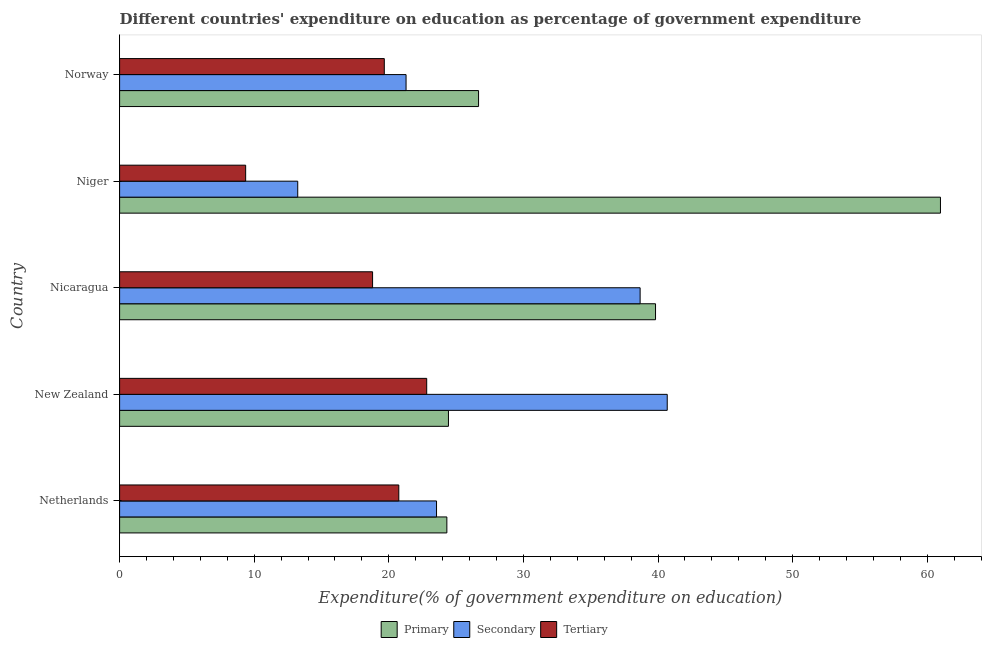How many different coloured bars are there?
Make the answer very short. 3. Are the number of bars per tick equal to the number of legend labels?
Offer a very short reply. Yes. How many bars are there on the 5th tick from the top?
Your response must be concise. 3. How many bars are there on the 1st tick from the bottom?
Provide a short and direct response. 3. What is the label of the 5th group of bars from the top?
Offer a terse response. Netherlands. What is the expenditure on tertiary education in Nicaragua?
Keep it short and to the point. 18.79. Across all countries, what is the maximum expenditure on primary education?
Keep it short and to the point. 60.98. Across all countries, what is the minimum expenditure on primary education?
Your response must be concise. 24.31. In which country was the expenditure on secondary education maximum?
Give a very brief answer. New Zealand. In which country was the expenditure on tertiary education minimum?
Offer a very short reply. Niger. What is the total expenditure on secondary education in the graph?
Offer a terse response. 137.41. What is the difference between the expenditure on primary education in New Zealand and that in Nicaragua?
Keep it short and to the point. -15.38. What is the difference between the expenditure on tertiary education in Netherlands and the expenditure on primary education in Niger?
Offer a very short reply. -40.24. What is the average expenditure on tertiary education per country?
Provide a short and direct response. 18.27. What is the difference between the expenditure on secondary education and expenditure on tertiary education in Norway?
Ensure brevity in your answer.  1.62. What is the ratio of the expenditure on primary education in Netherlands to that in Nicaragua?
Provide a short and direct response. 0.61. Is the expenditure on primary education in Netherlands less than that in Norway?
Make the answer very short. Yes. What is the difference between the highest and the second highest expenditure on tertiary education?
Provide a succinct answer. 2.07. What is the difference between the highest and the lowest expenditure on tertiary education?
Ensure brevity in your answer.  13.45. In how many countries, is the expenditure on primary education greater than the average expenditure on primary education taken over all countries?
Offer a very short reply. 2. Is the sum of the expenditure on secondary education in New Zealand and Nicaragua greater than the maximum expenditure on tertiary education across all countries?
Make the answer very short. Yes. What does the 2nd bar from the top in Niger represents?
Offer a very short reply. Secondary. What does the 2nd bar from the bottom in New Zealand represents?
Keep it short and to the point. Secondary. How many countries are there in the graph?
Offer a very short reply. 5. What is the difference between two consecutive major ticks on the X-axis?
Offer a terse response. 10. Does the graph contain any zero values?
Offer a terse response. No. Does the graph contain grids?
Offer a terse response. No. How are the legend labels stacked?
Offer a very short reply. Horizontal. What is the title of the graph?
Your response must be concise. Different countries' expenditure on education as percentage of government expenditure. Does "Poland" appear as one of the legend labels in the graph?
Your response must be concise. No. What is the label or title of the X-axis?
Provide a short and direct response. Expenditure(% of government expenditure on education). What is the label or title of the Y-axis?
Provide a short and direct response. Country. What is the Expenditure(% of government expenditure on education) in Primary in Netherlands?
Ensure brevity in your answer.  24.31. What is the Expenditure(% of government expenditure on education) of Secondary in Netherlands?
Your answer should be very brief. 23.54. What is the Expenditure(% of government expenditure on education) in Tertiary in Netherlands?
Provide a short and direct response. 20.74. What is the Expenditure(% of government expenditure on education) of Primary in New Zealand?
Make the answer very short. 24.43. What is the Expenditure(% of government expenditure on education) of Secondary in New Zealand?
Your response must be concise. 40.68. What is the Expenditure(% of government expenditure on education) in Tertiary in New Zealand?
Offer a terse response. 22.81. What is the Expenditure(% of government expenditure on education) of Primary in Nicaragua?
Your answer should be very brief. 39.81. What is the Expenditure(% of government expenditure on education) in Secondary in Nicaragua?
Your answer should be compact. 38.67. What is the Expenditure(% of government expenditure on education) of Tertiary in Nicaragua?
Provide a short and direct response. 18.79. What is the Expenditure(% of government expenditure on education) of Primary in Niger?
Provide a succinct answer. 60.98. What is the Expenditure(% of government expenditure on education) of Secondary in Niger?
Provide a short and direct response. 13.23. What is the Expenditure(% of government expenditure on education) of Tertiary in Niger?
Provide a short and direct response. 9.36. What is the Expenditure(% of government expenditure on education) of Primary in Norway?
Your answer should be compact. 26.67. What is the Expenditure(% of government expenditure on education) in Secondary in Norway?
Ensure brevity in your answer.  21.28. What is the Expenditure(% of government expenditure on education) of Tertiary in Norway?
Ensure brevity in your answer.  19.66. Across all countries, what is the maximum Expenditure(% of government expenditure on education) of Primary?
Keep it short and to the point. 60.98. Across all countries, what is the maximum Expenditure(% of government expenditure on education) in Secondary?
Make the answer very short. 40.68. Across all countries, what is the maximum Expenditure(% of government expenditure on education) in Tertiary?
Your answer should be very brief. 22.81. Across all countries, what is the minimum Expenditure(% of government expenditure on education) in Primary?
Keep it short and to the point. 24.31. Across all countries, what is the minimum Expenditure(% of government expenditure on education) of Secondary?
Offer a very short reply. 13.23. Across all countries, what is the minimum Expenditure(% of government expenditure on education) in Tertiary?
Keep it short and to the point. 9.36. What is the total Expenditure(% of government expenditure on education) of Primary in the graph?
Ensure brevity in your answer.  176.2. What is the total Expenditure(% of government expenditure on education) of Secondary in the graph?
Your answer should be very brief. 137.41. What is the total Expenditure(% of government expenditure on education) in Tertiary in the graph?
Your answer should be compact. 91.37. What is the difference between the Expenditure(% of government expenditure on education) of Primary in Netherlands and that in New Zealand?
Your response must be concise. -0.12. What is the difference between the Expenditure(% of government expenditure on education) in Secondary in Netherlands and that in New Zealand?
Your answer should be compact. -17.14. What is the difference between the Expenditure(% of government expenditure on education) in Tertiary in Netherlands and that in New Zealand?
Offer a very short reply. -2.07. What is the difference between the Expenditure(% of government expenditure on education) in Primary in Netherlands and that in Nicaragua?
Give a very brief answer. -15.5. What is the difference between the Expenditure(% of government expenditure on education) of Secondary in Netherlands and that in Nicaragua?
Provide a succinct answer. -15.12. What is the difference between the Expenditure(% of government expenditure on education) in Tertiary in Netherlands and that in Nicaragua?
Ensure brevity in your answer.  1.95. What is the difference between the Expenditure(% of government expenditure on education) in Primary in Netherlands and that in Niger?
Make the answer very short. -36.67. What is the difference between the Expenditure(% of government expenditure on education) in Secondary in Netherlands and that in Niger?
Offer a very short reply. 10.31. What is the difference between the Expenditure(% of government expenditure on education) in Tertiary in Netherlands and that in Niger?
Keep it short and to the point. 11.38. What is the difference between the Expenditure(% of government expenditure on education) of Primary in Netherlands and that in Norway?
Keep it short and to the point. -2.36. What is the difference between the Expenditure(% of government expenditure on education) in Secondary in Netherlands and that in Norway?
Your answer should be compact. 2.26. What is the difference between the Expenditure(% of government expenditure on education) of Tertiary in Netherlands and that in Norway?
Ensure brevity in your answer.  1.08. What is the difference between the Expenditure(% of government expenditure on education) of Primary in New Zealand and that in Nicaragua?
Offer a terse response. -15.38. What is the difference between the Expenditure(% of government expenditure on education) in Secondary in New Zealand and that in Nicaragua?
Your response must be concise. 2.01. What is the difference between the Expenditure(% of government expenditure on education) in Tertiary in New Zealand and that in Nicaragua?
Your answer should be very brief. 4.02. What is the difference between the Expenditure(% of government expenditure on education) in Primary in New Zealand and that in Niger?
Make the answer very short. -36.55. What is the difference between the Expenditure(% of government expenditure on education) of Secondary in New Zealand and that in Niger?
Make the answer very short. 27.45. What is the difference between the Expenditure(% of government expenditure on education) in Tertiary in New Zealand and that in Niger?
Provide a short and direct response. 13.45. What is the difference between the Expenditure(% of government expenditure on education) in Primary in New Zealand and that in Norway?
Keep it short and to the point. -2.24. What is the difference between the Expenditure(% of government expenditure on education) of Secondary in New Zealand and that in Norway?
Provide a short and direct response. 19.4. What is the difference between the Expenditure(% of government expenditure on education) in Tertiary in New Zealand and that in Norway?
Your answer should be compact. 3.15. What is the difference between the Expenditure(% of government expenditure on education) in Primary in Nicaragua and that in Niger?
Your answer should be very brief. -21.17. What is the difference between the Expenditure(% of government expenditure on education) of Secondary in Nicaragua and that in Niger?
Provide a succinct answer. 25.44. What is the difference between the Expenditure(% of government expenditure on education) of Tertiary in Nicaragua and that in Niger?
Your answer should be very brief. 9.43. What is the difference between the Expenditure(% of government expenditure on education) of Primary in Nicaragua and that in Norway?
Provide a succinct answer. 13.15. What is the difference between the Expenditure(% of government expenditure on education) of Secondary in Nicaragua and that in Norway?
Provide a succinct answer. 17.39. What is the difference between the Expenditure(% of government expenditure on education) in Tertiary in Nicaragua and that in Norway?
Your response must be concise. -0.87. What is the difference between the Expenditure(% of government expenditure on education) in Primary in Niger and that in Norway?
Provide a succinct answer. 34.31. What is the difference between the Expenditure(% of government expenditure on education) of Secondary in Niger and that in Norway?
Your response must be concise. -8.05. What is the difference between the Expenditure(% of government expenditure on education) of Tertiary in Niger and that in Norway?
Your answer should be very brief. -10.3. What is the difference between the Expenditure(% of government expenditure on education) in Primary in Netherlands and the Expenditure(% of government expenditure on education) in Secondary in New Zealand?
Your answer should be compact. -16.37. What is the difference between the Expenditure(% of government expenditure on education) of Primary in Netherlands and the Expenditure(% of government expenditure on education) of Tertiary in New Zealand?
Offer a very short reply. 1.5. What is the difference between the Expenditure(% of government expenditure on education) in Secondary in Netherlands and the Expenditure(% of government expenditure on education) in Tertiary in New Zealand?
Keep it short and to the point. 0.73. What is the difference between the Expenditure(% of government expenditure on education) of Primary in Netherlands and the Expenditure(% of government expenditure on education) of Secondary in Nicaragua?
Give a very brief answer. -14.36. What is the difference between the Expenditure(% of government expenditure on education) in Primary in Netherlands and the Expenditure(% of government expenditure on education) in Tertiary in Nicaragua?
Your answer should be very brief. 5.52. What is the difference between the Expenditure(% of government expenditure on education) of Secondary in Netherlands and the Expenditure(% of government expenditure on education) of Tertiary in Nicaragua?
Offer a very short reply. 4.75. What is the difference between the Expenditure(% of government expenditure on education) of Primary in Netherlands and the Expenditure(% of government expenditure on education) of Secondary in Niger?
Your answer should be compact. 11.08. What is the difference between the Expenditure(% of government expenditure on education) of Primary in Netherlands and the Expenditure(% of government expenditure on education) of Tertiary in Niger?
Your response must be concise. 14.95. What is the difference between the Expenditure(% of government expenditure on education) of Secondary in Netherlands and the Expenditure(% of government expenditure on education) of Tertiary in Niger?
Provide a short and direct response. 14.18. What is the difference between the Expenditure(% of government expenditure on education) in Primary in Netherlands and the Expenditure(% of government expenditure on education) in Secondary in Norway?
Keep it short and to the point. 3.03. What is the difference between the Expenditure(% of government expenditure on education) of Primary in Netherlands and the Expenditure(% of government expenditure on education) of Tertiary in Norway?
Your answer should be very brief. 4.65. What is the difference between the Expenditure(% of government expenditure on education) in Secondary in Netherlands and the Expenditure(% of government expenditure on education) in Tertiary in Norway?
Make the answer very short. 3.88. What is the difference between the Expenditure(% of government expenditure on education) of Primary in New Zealand and the Expenditure(% of government expenditure on education) of Secondary in Nicaragua?
Give a very brief answer. -14.24. What is the difference between the Expenditure(% of government expenditure on education) of Primary in New Zealand and the Expenditure(% of government expenditure on education) of Tertiary in Nicaragua?
Ensure brevity in your answer.  5.64. What is the difference between the Expenditure(% of government expenditure on education) of Secondary in New Zealand and the Expenditure(% of government expenditure on education) of Tertiary in Nicaragua?
Provide a short and direct response. 21.89. What is the difference between the Expenditure(% of government expenditure on education) in Primary in New Zealand and the Expenditure(% of government expenditure on education) in Secondary in Niger?
Ensure brevity in your answer.  11.2. What is the difference between the Expenditure(% of government expenditure on education) in Primary in New Zealand and the Expenditure(% of government expenditure on education) in Tertiary in Niger?
Give a very brief answer. 15.06. What is the difference between the Expenditure(% of government expenditure on education) in Secondary in New Zealand and the Expenditure(% of government expenditure on education) in Tertiary in Niger?
Your response must be concise. 31.32. What is the difference between the Expenditure(% of government expenditure on education) in Primary in New Zealand and the Expenditure(% of government expenditure on education) in Secondary in Norway?
Keep it short and to the point. 3.15. What is the difference between the Expenditure(% of government expenditure on education) of Primary in New Zealand and the Expenditure(% of government expenditure on education) of Tertiary in Norway?
Offer a terse response. 4.77. What is the difference between the Expenditure(% of government expenditure on education) in Secondary in New Zealand and the Expenditure(% of government expenditure on education) in Tertiary in Norway?
Give a very brief answer. 21.02. What is the difference between the Expenditure(% of government expenditure on education) in Primary in Nicaragua and the Expenditure(% of government expenditure on education) in Secondary in Niger?
Your response must be concise. 26.58. What is the difference between the Expenditure(% of government expenditure on education) in Primary in Nicaragua and the Expenditure(% of government expenditure on education) in Tertiary in Niger?
Offer a very short reply. 30.45. What is the difference between the Expenditure(% of government expenditure on education) of Secondary in Nicaragua and the Expenditure(% of government expenditure on education) of Tertiary in Niger?
Give a very brief answer. 29.3. What is the difference between the Expenditure(% of government expenditure on education) of Primary in Nicaragua and the Expenditure(% of government expenditure on education) of Secondary in Norway?
Provide a succinct answer. 18.53. What is the difference between the Expenditure(% of government expenditure on education) in Primary in Nicaragua and the Expenditure(% of government expenditure on education) in Tertiary in Norway?
Provide a succinct answer. 20.15. What is the difference between the Expenditure(% of government expenditure on education) of Secondary in Nicaragua and the Expenditure(% of government expenditure on education) of Tertiary in Norway?
Offer a terse response. 19. What is the difference between the Expenditure(% of government expenditure on education) in Primary in Niger and the Expenditure(% of government expenditure on education) in Secondary in Norway?
Your answer should be very brief. 39.7. What is the difference between the Expenditure(% of government expenditure on education) of Primary in Niger and the Expenditure(% of government expenditure on education) of Tertiary in Norway?
Your answer should be very brief. 41.31. What is the difference between the Expenditure(% of government expenditure on education) in Secondary in Niger and the Expenditure(% of government expenditure on education) in Tertiary in Norway?
Ensure brevity in your answer.  -6.43. What is the average Expenditure(% of government expenditure on education) of Primary per country?
Provide a short and direct response. 35.24. What is the average Expenditure(% of government expenditure on education) of Secondary per country?
Ensure brevity in your answer.  27.48. What is the average Expenditure(% of government expenditure on education) of Tertiary per country?
Ensure brevity in your answer.  18.27. What is the difference between the Expenditure(% of government expenditure on education) in Primary and Expenditure(% of government expenditure on education) in Secondary in Netherlands?
Offer a very short reply. 0.77. What is the difference between the Expenditure(% of government expenditure on education) of Primary and Expenditure(% of government expenditure on education) of Tertiary in Netherlands?
Provide a short and direct response. 3.57. What is the difference between the Expenditure(% of government expenditure on education) in Secondary and Expenditure(% of government expenditure on education) in Tertiary in Netherlands?
Keep it short and to the point. 2.8. What is the difference between the Expenditure(% of government expenditure on education) in Primary and Expenditure(% of government expenditure on education) in Secondary in New Zealand?
Offer a terse response. -16.25. What is the difference between the Expenditure(% of government expenditure on education) of Primary and Expenditure(% of government expenditure on education) of Tertiary in New Zealand?
Provide a succinct answer. 1.62. What is the difference between the Expenditure(% of government expenditure on education) of Secondary and Expenditure(% of government expenditure on education) of Tertiary in New Zealand?
Ensure brevity in your answer.  17.87. What is the difference between the Expenditure(% of government expenditure on education) in Primary and Expenditure(% of government expenditure on education) in Secondary in Nicaragua?
Give a very brief answer. 1.14. What is the difference between the Expenditure(% of government expenditure on education) in Primary and Expenditure(% of government expenditure on education) in Tertiary in Nicaragua?
Offer a terse response. 21.02. What is the difference between the Expenditure(% of government expenditure on education) in Secondary and Expenditure(% of government expenditure on education) in Tertiary in Nicaragua?
Keep it short and to the point. 19.88. What is the difference between the Expenditure(% of government expenditure on education) of Primary and Expenditure(% of government expenditure on education) of Secondary in Niger?
Offer a very short reply. 47.74. What is the difference between the Expenditure(% of government expenditure on education) of Primary and Expenditure(% of government expenditure on education) of Tertiary in Niger?
Provide a short and direct response. 51.61. What is the difference between the Expenditure(% of government expenditure on education) of Secondary and Expenditure(% of government expenditure on education) of Tertiary in Niger?
Provide a short and direct response. 3.87. What is the difference between the Expenditure(% of government expenditure on education) in Primary and Expenditure(% of government expenditure on education) in Secondary in Norway?
Provide a succinct answer. 5.39. What is the difference between the Expenditure(% of government expenditure on education) in Primary and Expenditure(% of government expenditure on education) in Tertiary in Norway?
Keep it short and to the point. 7. What is the difference between the Expenditure(% of government expenditure on education) in Secondary and Expenditure(% of government expenditure on education) in Tertiary in Norway?
Keep it short and to the point. 1.62. What is the ratio of the Expenditure(% of government expenditure on education) in Secondary in Netherlands to that in New Zealand?
Give a very brief answer. 0.58. What is the ratio of the Expenditure(% of government expenditure on education) of Primary in Netherlands to that in Nicaragua?
Provide a succinct answer. 0.61. What is the ratio of the Expenditure(% of government expenditure on education) in Secondary in Netherlands to that in Nicaragua?
Offer a very short reply. 0.61. What is the ratio of the Expenditure(% of government expenditure on education) of Tertiary in Netherlands to that in Nicaragua?
Offer a terse response. 1.1. What is the ratio of the Expenditure(% of government expenditure on education) in Primary in Netherlands to that in Niger?
Offer a terse response. 0.4. What is the ratio of the Expenditure(% of government expenditure on education) in Secondary in Netherlands to that in Niger?
Offer a very short reply. 1.78. What is the ratio of the Expenditure(% of government expenditure on education) of Tertiary in Netherlands to that in Niger?
Offer a terse response. 2.21. What is the ratio of the Expenditure(% of government expenditure on education) in Primary in Netherlands to that in Norway?
Your answer should be compact. 0.91. What is the ratio of the Expenditure(% of government expenditure on education) in Secondary in Netherlands to that in Norway?
Provide a succinct answer. 1.11. What is the ratio of the Expenditure(% of government expenditure on education) in Tertiary in Netherlands to that in Norway?
Your response must be concise. 1.05. What is the ratio of the Expenditure(% of government expenditure on education) of Primary in New Zealand to that in Nicaragua?
Give a very brief answer. 0.61. What is the ratio of the Expenditure(% of government expenditure on education) in Secondary in New Zealand to that in Nicaragua?
Provide a short and direct response. 1.05. What is the ratio of the Expenditure(% of government expenditure on education) of Tertiary in New Zealand to that in Nicaragua?
Your answer should be very brief. 1.21. What is the ratio of the Expenditure(% of government expenditure on education) in Primary in New Zealand to that in Niger?
Make the answer very short. 0.4. What is the ratio of the Expenditure(% of government expenditure on education) in Secondary in New Zealand to that in Niger?
Ensure brevity in your answer.  3.07. What is the ratio of the Expenditure(% of government expenditure on education) in Tertiary in New Zealand to that in Niger?
Offer a terse response. 2.44. What is the ratio of the Expenditure(% of government expenditure on education) of Primary in New Zealand to that in Norway?
Provide a succinct answer. 0.92. What is the ratio of the Expenditure(% of government expenditure on education) of Secondary in New Zealand to that in Norway?
Your answer should be compact. 1.91. What is the ratio of the Expenditure(% of government expenditure on education) of Tertiary in New Zealand to that in Norway?
Keep it short and to the point. 1.16. What is the ratio of the Expenditure(% of government expenditure on education) of Primary in Nicaragua to that in Niger?
Your answer should be very brief. 0.65. What is the ratio of the Expenditure(% of government expenditure on education) in Secondary in Nicaragua to that in Niger?
Make the answer very short. 2.92. What is the ratio of the Expenditure(% of government expenditure on education) of Tertiary in Nicaragua to that in Niger?
Your response must be concise. 2.01. What is the ratio of the Expenditure(% of government expenditure on education) in Primary in Nicaragua to that in Norway?
Your response must be concise. 1.49. What is the ratio of the Expenditure(% of government expenditure on education) in Secondary in Nicaragua to that in Norway?
Provide a succinct answer. 1.82. What is the ratio of the Expenditure(% of government expenditure on education) in Tertiary in Nicaragua to that in Norway?
Offer a very short reply. 0.96. What is the ratio of the Expenditure(% of government expenditure on education) in Primary in Niger to that in Norway?
Ensure brevity in your answer.  2.29. What is the ratio of the Expenditure(% of government expenditure on education) of Secondary in Niger to that in Norway?
Your answer should be compact. 0.62. What is the ratio of the Expenditure(% of government expenditure on education) in Tertiary in Niger to that in Norway?
Keep it short and to the point. 0.48. What is the difference between the highest and the second highest Expenditure(% of government expenditure on education) in Primary?
Keep it short and to the point. 21.17. What is the difference between the highest and the second highest Expenditure(% of government expenditure on education) in Secondary?
Your answer should be compact. 2.01. What is the difference between the highest and the second highest Expenditure(% of government expenditure on education) of Tertiary?
Make the answer very short. 2.07. What is the difference between the highest and the lowest Expenditure(% of government expenditure on education) of Primary?
Offer a terse response. 36.67. What is the difference between the highest and the lowest Expenditure(% of government expenditure on education) in Secondary?
Keep it short and to the point. 27.45. What is the difference between the highest and the lowest Expenditure(% of government expenditure on education) in Tertiary?
Your answer should be compact. 13.45. 